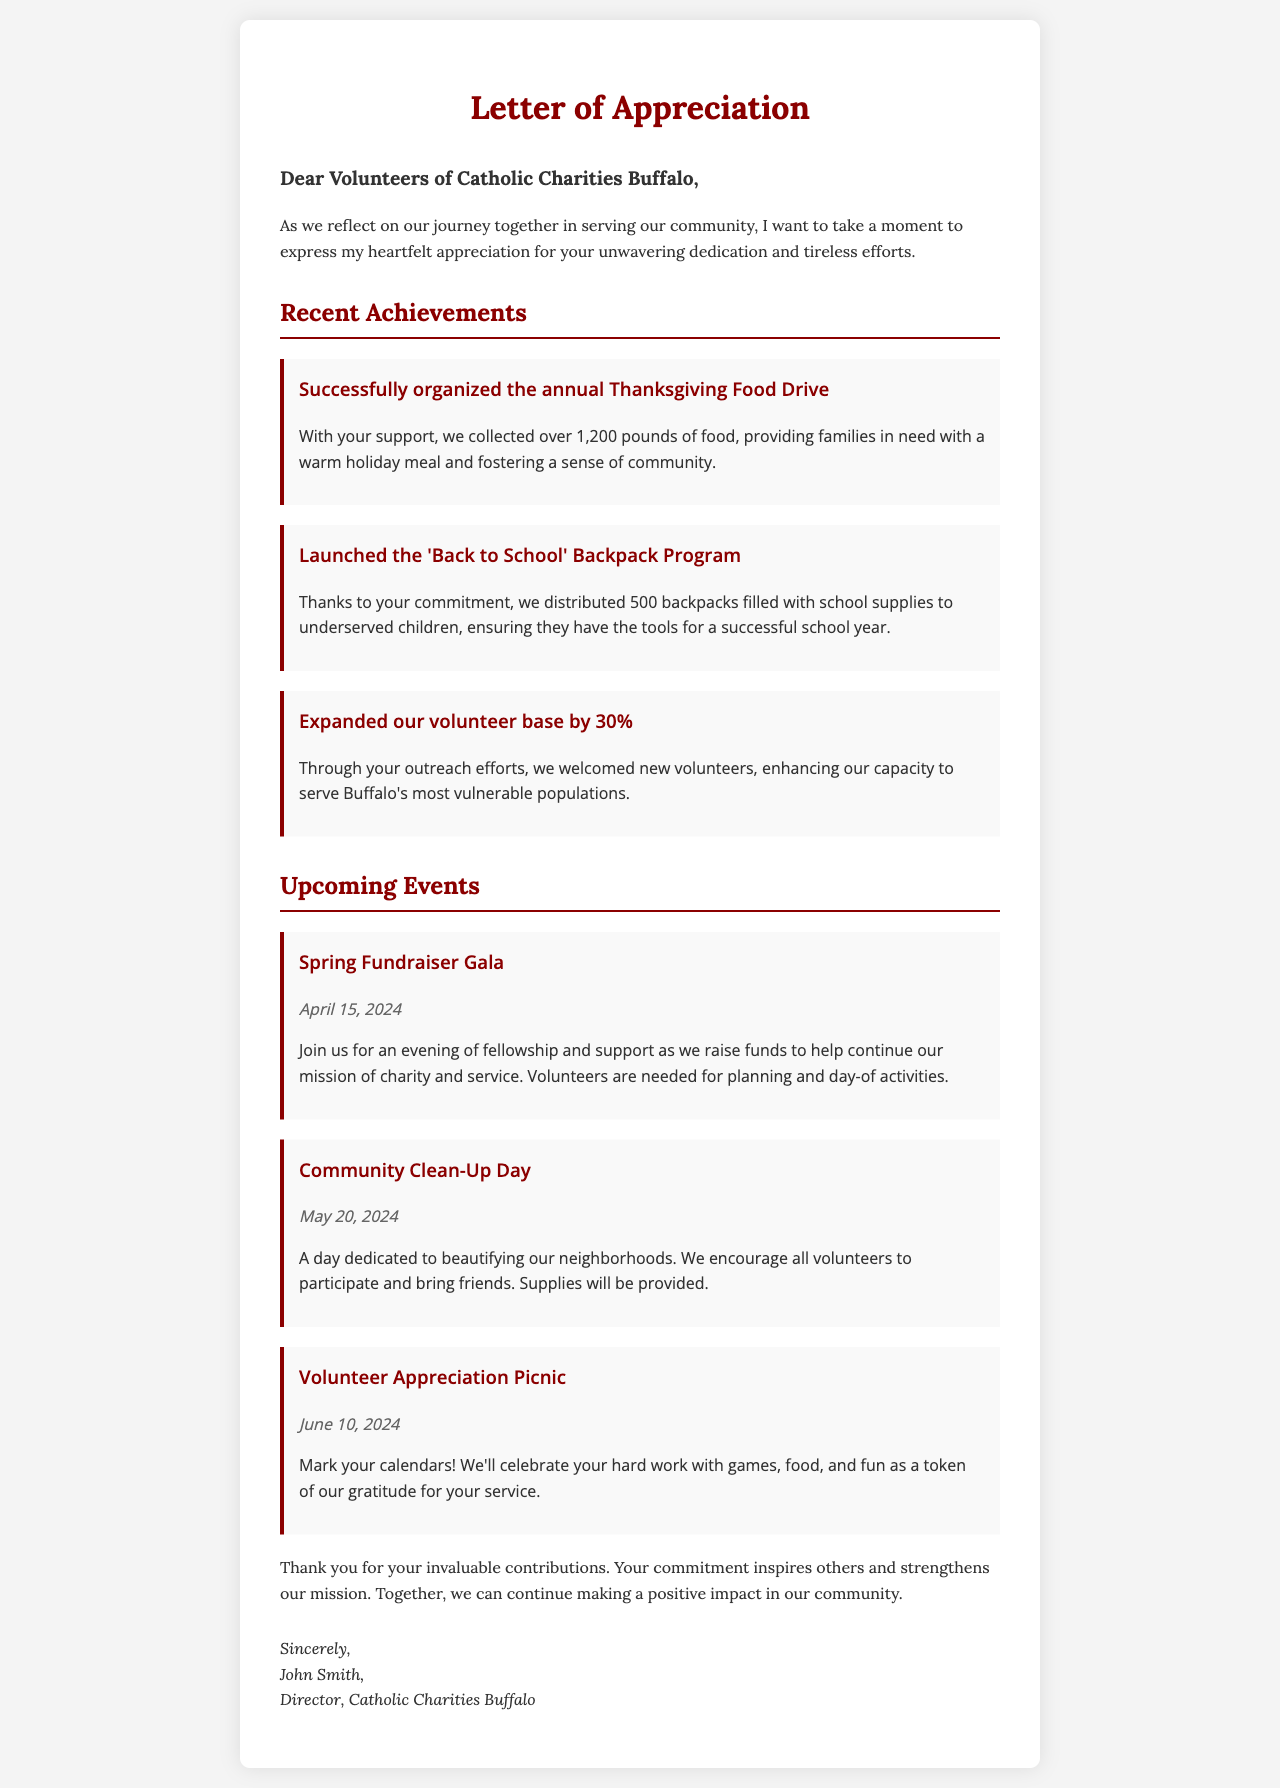What is the title of the letter? The title of the letter is prominently stated at the top of the document.
Answer: Letter of Appreciation Who is the letter addressed to? The greeting section indicates whom the letter is addressed to.
Answer: Volunteers of Catholic Charities Buffalo What is one of the recent achievements mentioned? The achievements section provides specific accomplishments made by the volunteers.
Answer: Successfully organized the annual Thanksgiving Food Drive How many pounds of food were collected during the Thanksgiving Food Drive? This detail is specified in the description of the achievement.
Answer: 1,200 pounds What date is the Spring Fundraiser Gala scheduled for? The event section lists the date for the upcoming events.
Answer: April 15, 2024 How many backpacks were distributed in the 'Back to School' Backpack Program? This information is provided in the description of the achievement related to the program.
Answer: 500 backpacks What is the purpose of the Community Clean-Up Day? The event section describes the main goal of this particular event.
Answer: Beautifying our neighborhoods What is the date for the Volunteer Appreciation Picnic? This date is specified in the events section of the letter.
Answer: June 10, 2024 Who wrote the letter? The signature section provides the name of the person who authored the letter.
Answer: John Smith 